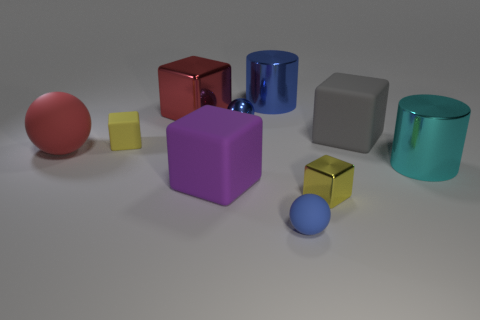Subtract 1 blocks. How many blocks are left? 4 Subtract all cyan blocks. Subtract all purple balls. How many blocks are left? 5 Subtract all cylinders. How many objects are left? 8 Add 3 tiny blue rubber things. How many tiny blue rubber things exist? 4 Subtract 0 cyan cubes. How many objects are left? 10 Subtract all big gray matte cubes. Subtract all blue shiny things. How many objects are left? 7 Add 7 large shiny things. How many large shiny things are left? 10 